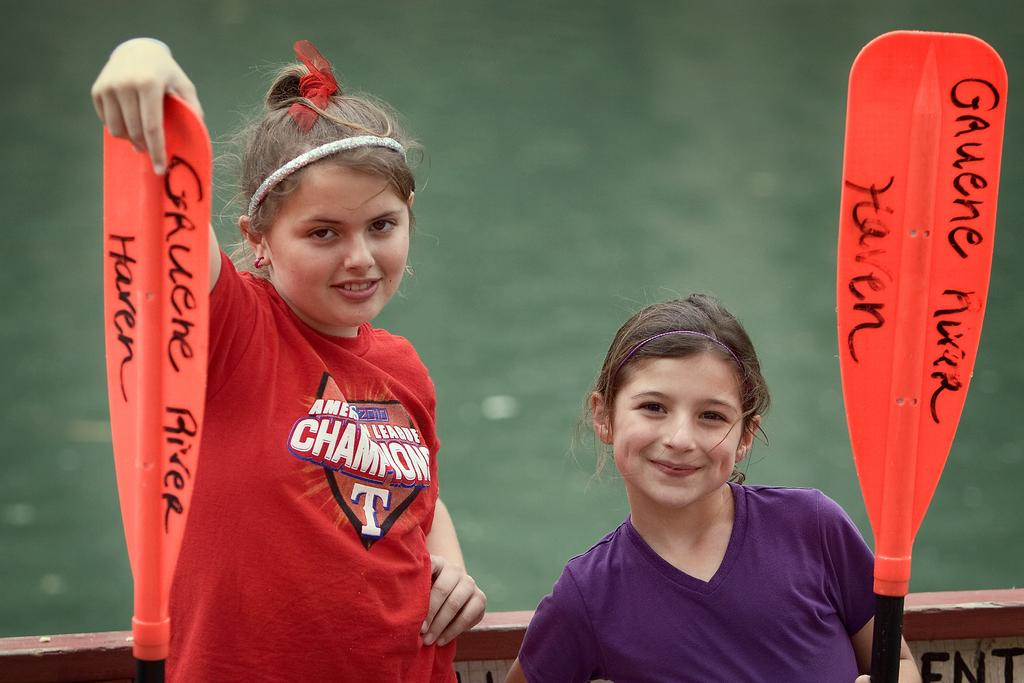<image>
Write a terse but informative summary of the picture. Two girls holding paddles near a river for the American league champions. 